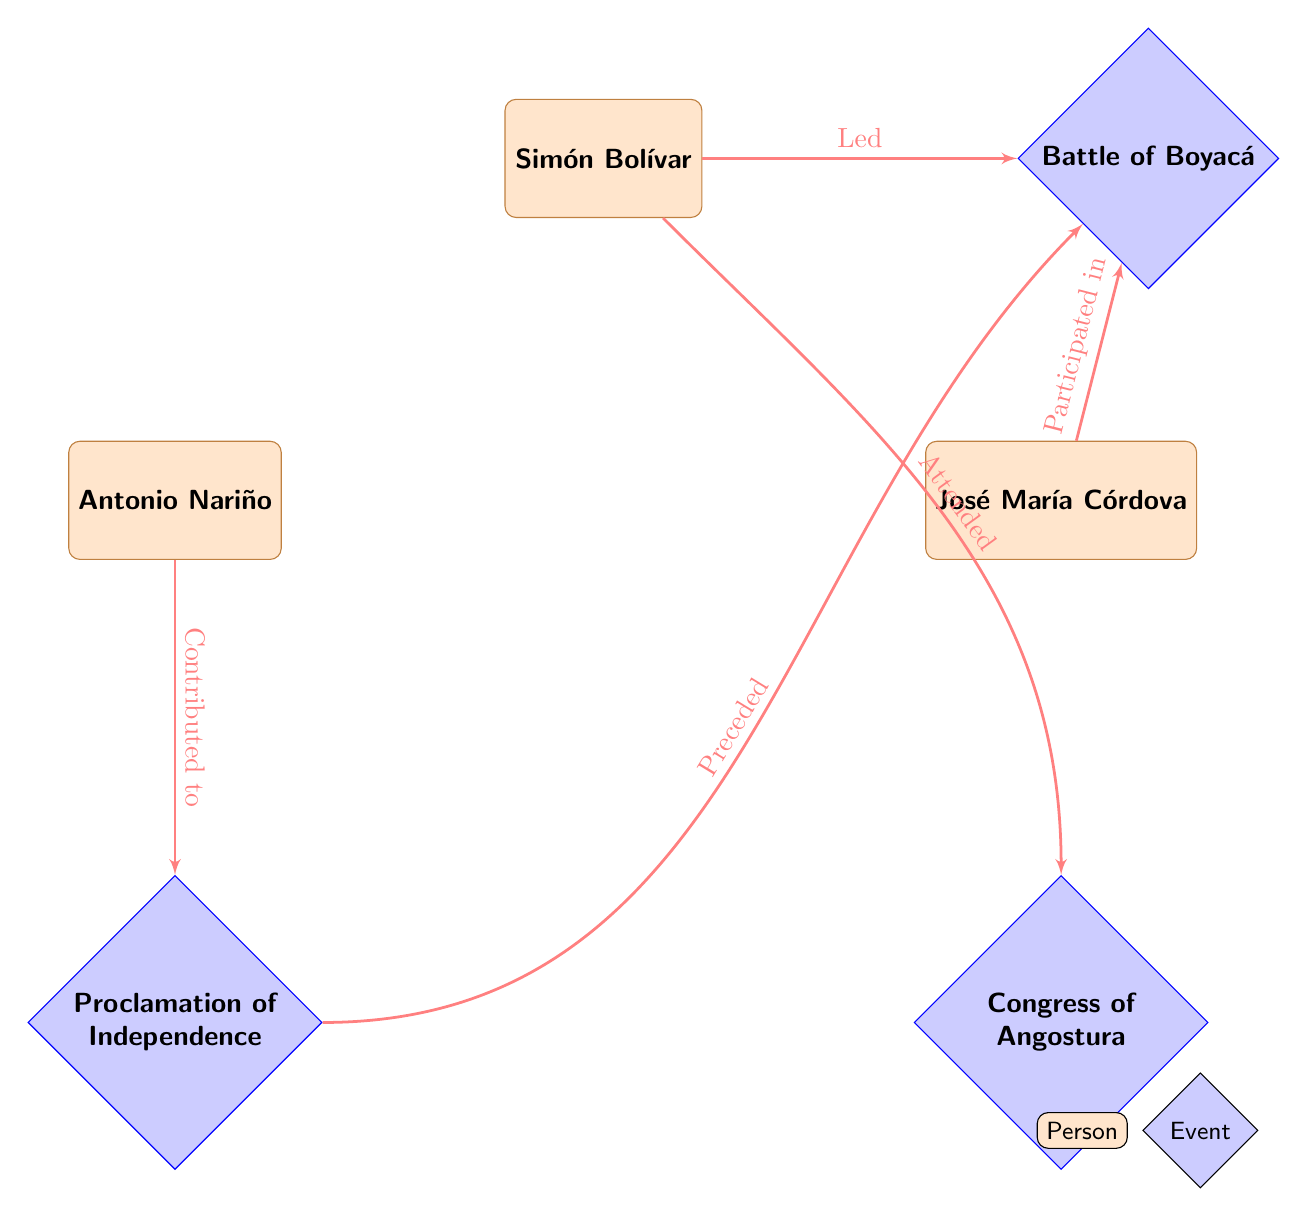What is the birth date of Simón Bolívar? According to the attributes listed under the entity Simón Bolívar in the diagram, the birth date is specifically mentioned.
Answer: Birth Date Who contributed to the Proclamation of Independence? The diagram shows Antonio Nariño has a direct relationship labeled "Contributed to" with the Proclamation of Independence. Therefore, he is the one noted for this contribution.
Answer: Antonio Nariño How many key figures are directly connected to the Battle of Boyacá? The diagram shows two entities related to the Battle of Boyacá: Simón Bolívar (who led it) and José María Córdova (who participated in it). Thus, there are two key figures connected to this event.
Answer: 2 What event preceded the Battle of Boyacá? According to the diagram, the Proclamation of Independence is indicated to have "Preceded" the Battle of Boyacá, establishing a chronological order between these two events.
Answer: Proclamation of Independence Which Congress did Simón Bolívar attend? The diagram specifies that Simón Bolívar has a relationship labeled "Attended" with the Congress of Angostura. This directly gives us the information regarding his attendance.
Answer: Congress of Angostura What role did José María Córdova have in the Battle of Boyacá? The diagram indicates that José María Córdova participated in the Battle of Boyacá, which describes his role within that context.
Answer: Participated in What was a key discussion topic at the Congress of Angostura? The diagram does not specify key discussions but mentions that this event has participants associated with it. Therefore, we can reasonably infer that the discussions would involve matters of independence.
Answer: Key Discussions (specifics not provided) Which battle is led by Simón Bolívar? The diagram shows a direct relationship from Simón Bolívar to the Battle of Boyacá, labeled "Led," confirming that he was the one leading this particular battle.
Answer: Battle of Boyacá 